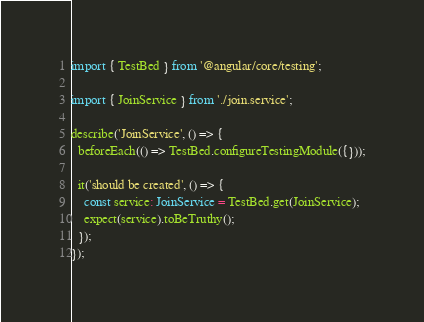Convert code to text. <code><loc_0><loc_0><loc_500><loc_500><_TypeScript_>import { TestBed } from '@angular/core/testing';

import { JoinService } from './join.service';

describe('JoinService', () => {
  beforeEach(() => TestBed.configureTestingModule({}));

  it('should be created', () => {
    const service: JoinService = TestBed.get(JoinService);
    expect(service).toBeTruthy();
  });
});
</code> 